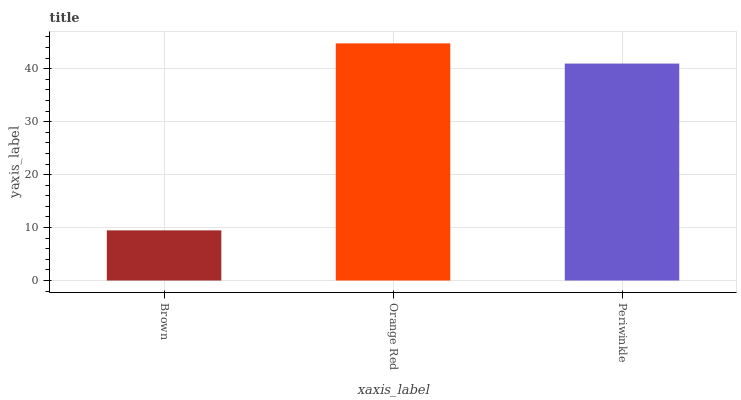Is Brown the minimum?
Answer yes or no. Yes. Is Orange Red the maximum?
Answer yes or no. Yes. Is Periwinkle the minimum?
Answer yes or no. No. Is Periwinkle the maximum?
Answer yes or no. No. Is Orange Red greater than Periwinkle?
Answer yes or no. Yes. Is Periwinkle less than Orange Red?
Answer yes or no. Yes. Is Periwinkle greater than Orange Red?
Answer yes or no. No. Is Orange Red less than Periwinkle?
Answer yes or no. No. Is Periwinkle the high median?
Answer yes or no. Yes. Is Periwinkle the low median?
Answer yes or no. Yes. Is Orange Red the high median?
Answer yes or no. No. Is Brown the low median?
Answer yes or no. No. 